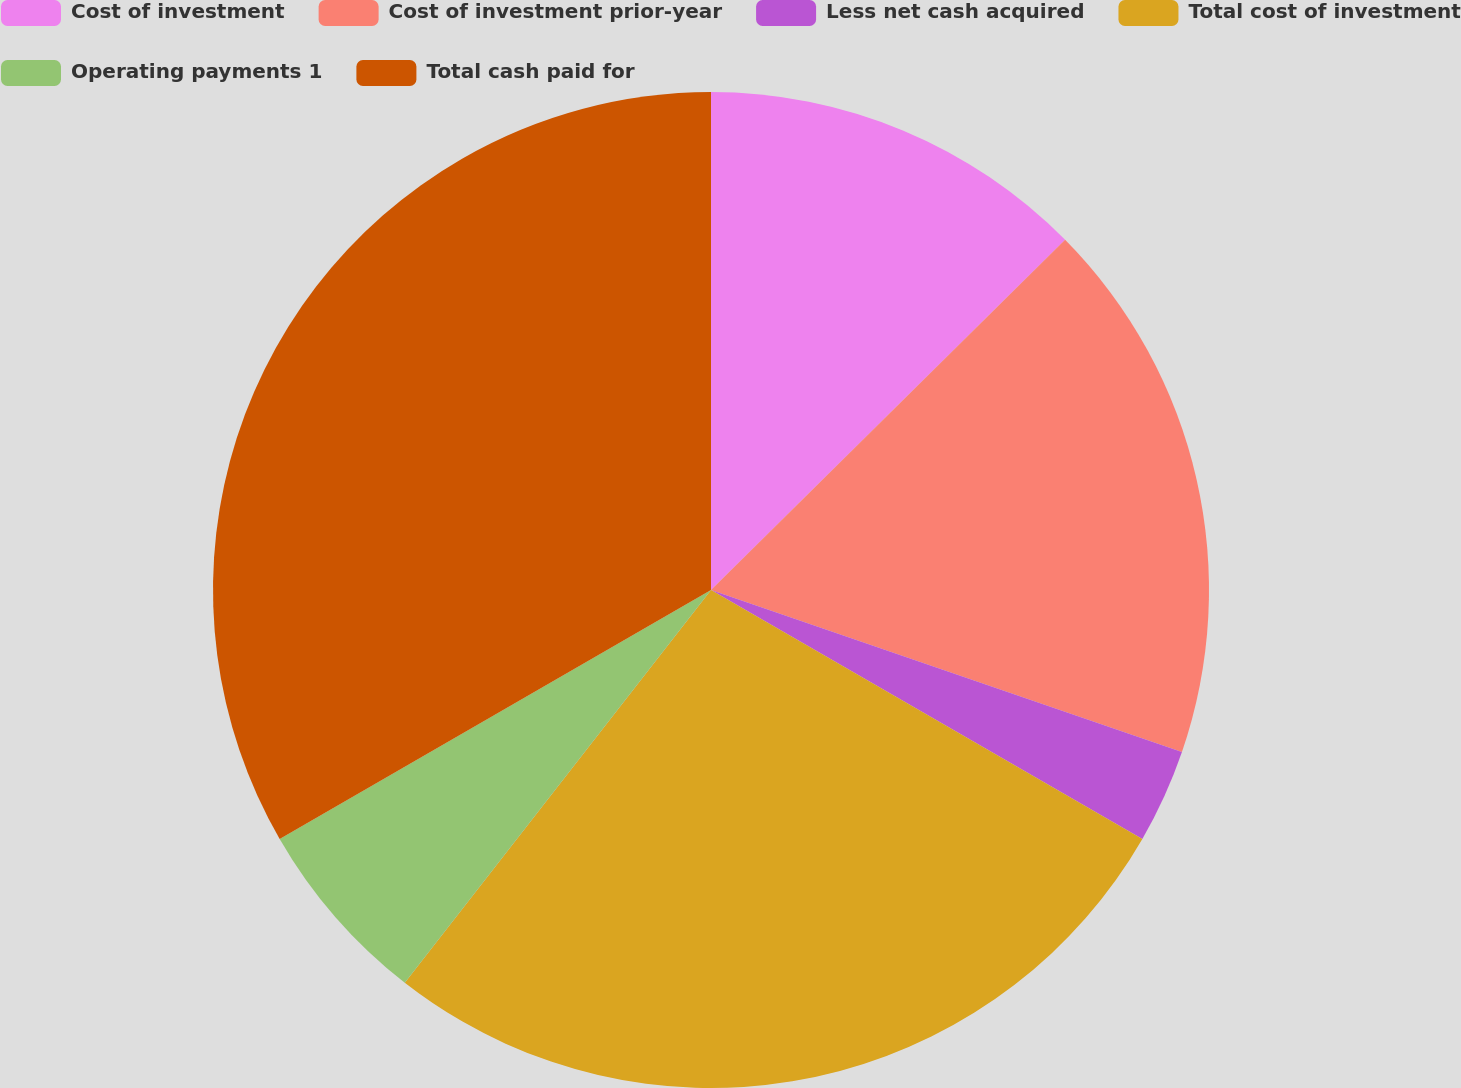<chart> <loc_0><loc_0><loc_500><loc_500><pie_chart><fcel>Cost of investment<fcel>Cost of investment prior-year<fcel>Less net cash acquired<fcel>Total cost of investment<fcel>Operating payments 1<fcel>Total cash paid for<nl><fcel>12.59%<fcel>17.68%<fcel>3.06%<fcel>27.21%<fcel>6.13%<fcel>33.33%<nl></chart> 